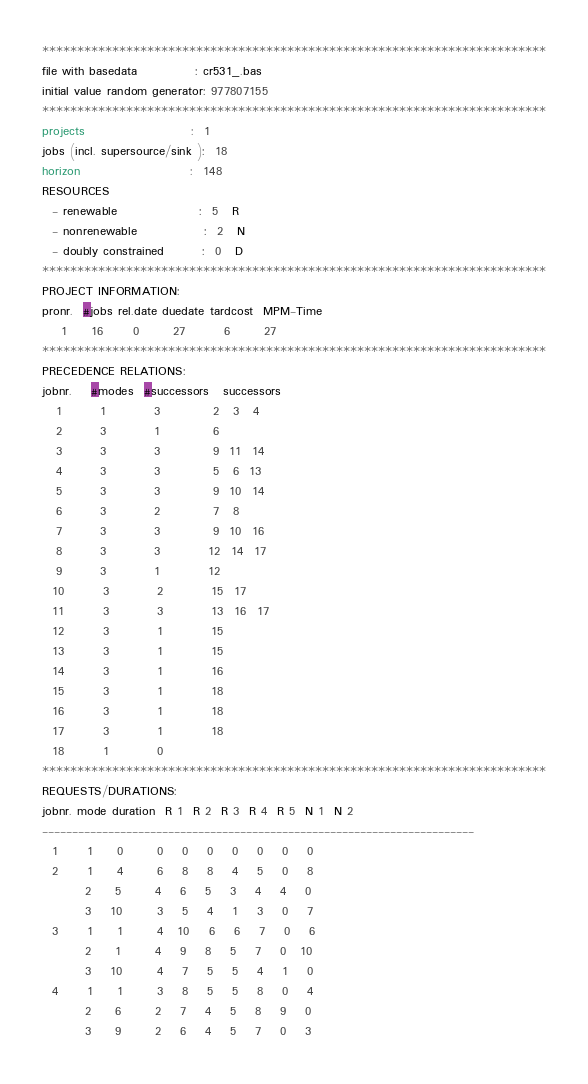<code> <loc_0><loc_0><loc_500><loc_500><_ObjectiveC_>************************************************************************
file with basedata            : cr531_.bas
initial value random generator: 977807155
************************************************************************
projects                      :  1
jobs (incl. supersource/sink ):  18
horizon                       :  148
RESOURCES
  - renewable                 :  5   R
  - nonrenewable              :  2   N
  - doubly constrained        :  0   D
************************************************************************
PROJECT INFORMATION:
pronr.  #jobs rel.date duedate tardcost  MPM-Time
    1     16      0       27        6       27
************************************************************************
PRECEDENCE RELATIONS:
jobnr.    #modes  #successors   successors
   1        1          3           2   3   4
   2        3          1           6
   3        3          3           9  11  14
   4        3          3           5   6  13
   5        3          3           9  10  14
   6        3          2           7   8
   7        3          3           9  10  16
   8        3          3          12  14  17
   9        3          1          12
  10        3          2          15  17
  11        3          3          13  16  17
  12        3          1          15
  13        3          1          15
  14        3          1          16
  15        3          1          18
  16        3          1          18
  17        3          1          18
  18        1          0        
************************************************************************
REQUESTS/DURATIONS:
jobnr. mode duration  R 1  R 2  R 3  R 4  R 5  N 1  N 2
------------------------------------------------------------------------
  1      1     0       0    0    0    0    0    0    0
  2      1     4       6    8    8    4    5    0    8
         2     5       4    6    5    3    4    4    0
         3    10       3    5    4    1    3    0    7
  3      1     1       4   10    6    6    7    0    6
         2     1       4    9    8    5    7    0   10
         3    10       4    7    5    5    4    1    0
  4      1     1       3    8    5    5    8    0    4
         2     6       2    7    4    5    8    9    0
         3     9       2    6    4    5    7    0    3</code> 